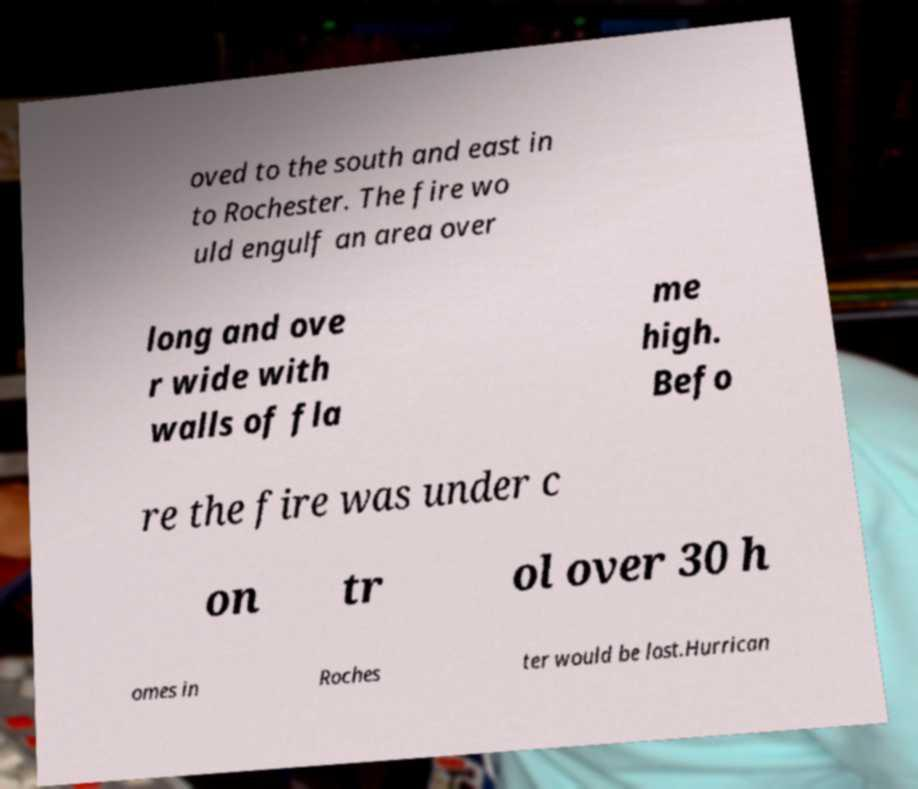There's text embedded in this image that I need extracted. Can you transcribe it verbatim? oved to the south and east in to Rochester. The fire wo uld engulf an area over long and ove r wide with walls of fla me high. Befo re the fire was under c on tr ol over 30 h omes in Roches ter would be lost.Hurrican 